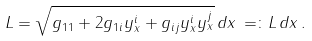<formula> <loc_0><loc_0><loc_500><loc_500>L = \sqrt { g _ { 1 1 } + 2 g _ { 1 i } y ^ { i } _ { x } + g _ { i j } y ^ { i } _ { x } y ^ { j } _ { x } } \, d x \, = \colon L \, d x \, .</formula> 